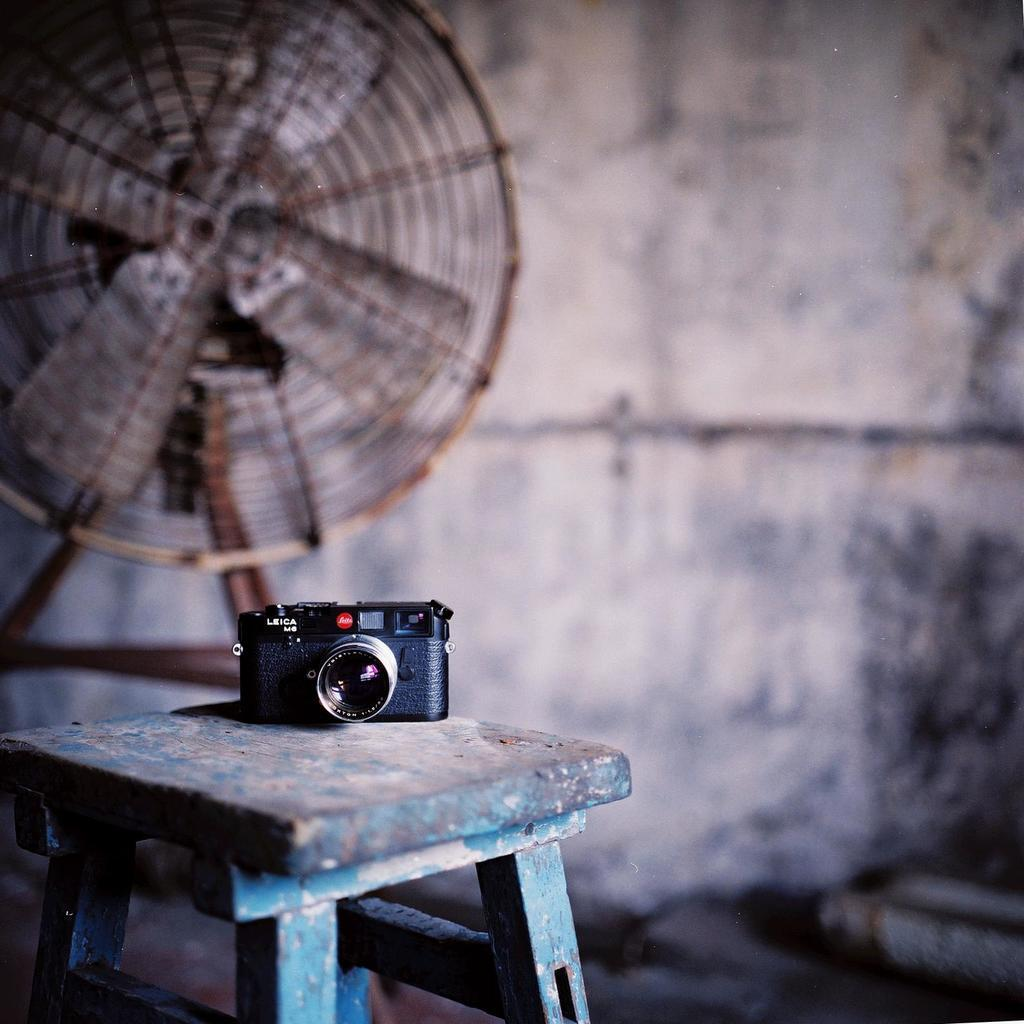What is the main subject of the image? There is a camera in the center of the image. How is the camera positioned in the image? The camera is on a stool. What can be seen in the background of the image? There is a table fan and a wall visible in the background of the image. Where is the bear sitting on the stage in the image? There is no bear or stage present in the image. The image only features a camera on a stool and a background with a table fan and a wall. 